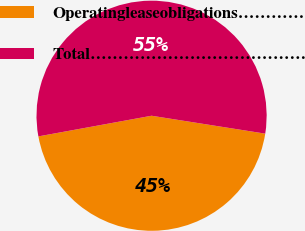<chart> <loc_0><loc_0><loc_500><loc_500><pie_chart><fcel>Operatingleaseobligations…………<fcel>Total…………………………………<nl><fcel>44.64%<fcel>55.36%<nl></chart> 